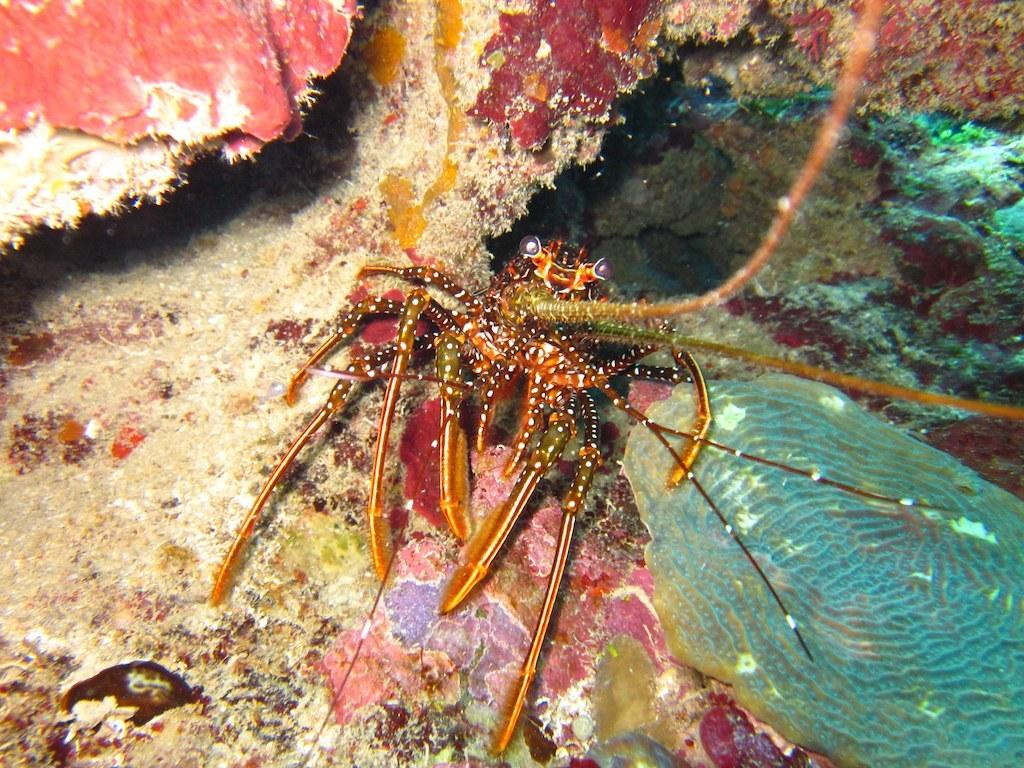What type of creature can be seen in the image? There is an insect in the image. What can be seen in the background of the image? There is moss in the background of the image. What else is present in the water in the background of the image? There are other objects in the water in the background of the image. What color is the skirt worn by the insect in the image? There is no skirt present in the image, as the main subject is an insect, which does not wear clothing. 